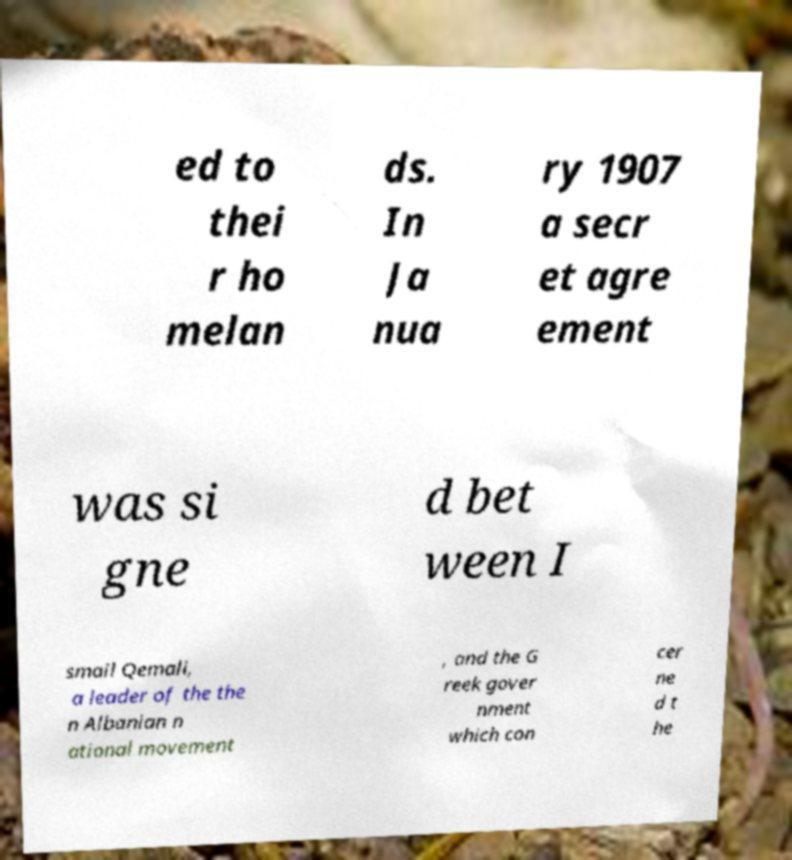For documentation purposes, I need the text within this image transcribed. Could you provide that? ed to thei r ho melan ds. In Ja nua ry 1907 a secr et agre ement was si gne d bet ween I smail Qemali, a leader of the the n Albanian n ational movement , and the G reek gover nment which con cer ne d t he 